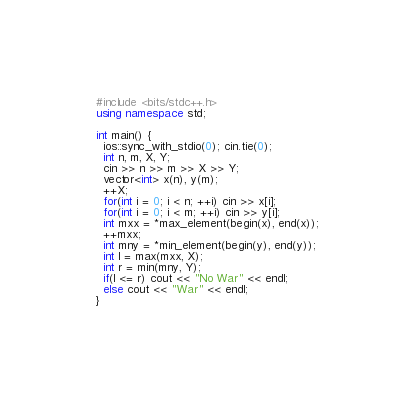<code> <loc_0><loc_0><loc_500><loc_500><_C++_>#include <bits/stdc++.h>
using namespace std;

int main() {
  ios::sync_with_stdio(0); cin.tie(0);
  int n, m, X, Y;
  cin >> n >> m >> X >> Y;
  vector<int> x(n), y(m);
  ++X;
  for(int i = 0; i < n; ++i) cin >> x[i];
  for(int i = 0; i < m; ++i) cin >> y[i];
  int mxx = *max_element(begin(x), end(x));
  ++mxx;
  int mny = *min_element(begin(y), end(y));
  int l = max(mxx, X);
  int r = min(mny, Y);
  if(l <= r) cout << "No War" << endl;
  else cout << "War" << endl;
}
</code> 